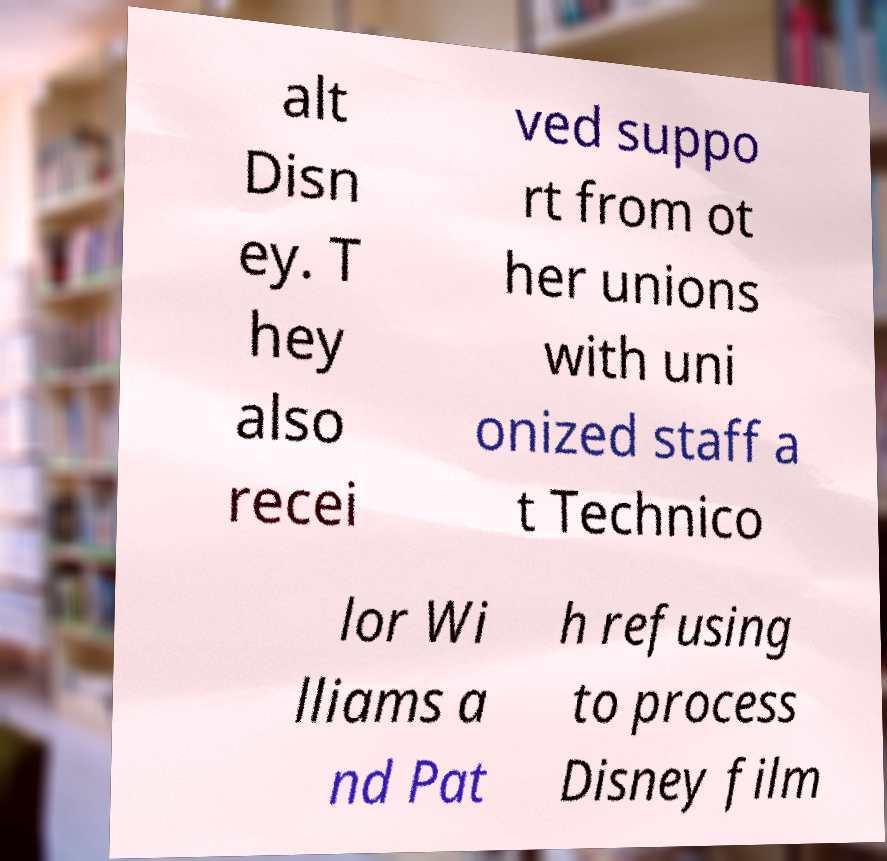Please identify and transcribe the text found in this image. alt Disn ey. T hey also recei ved suppo rt from ot her unions with uni onized staff a t Technico lor Wi lliams a nd Pat h refusing to process Disney film 